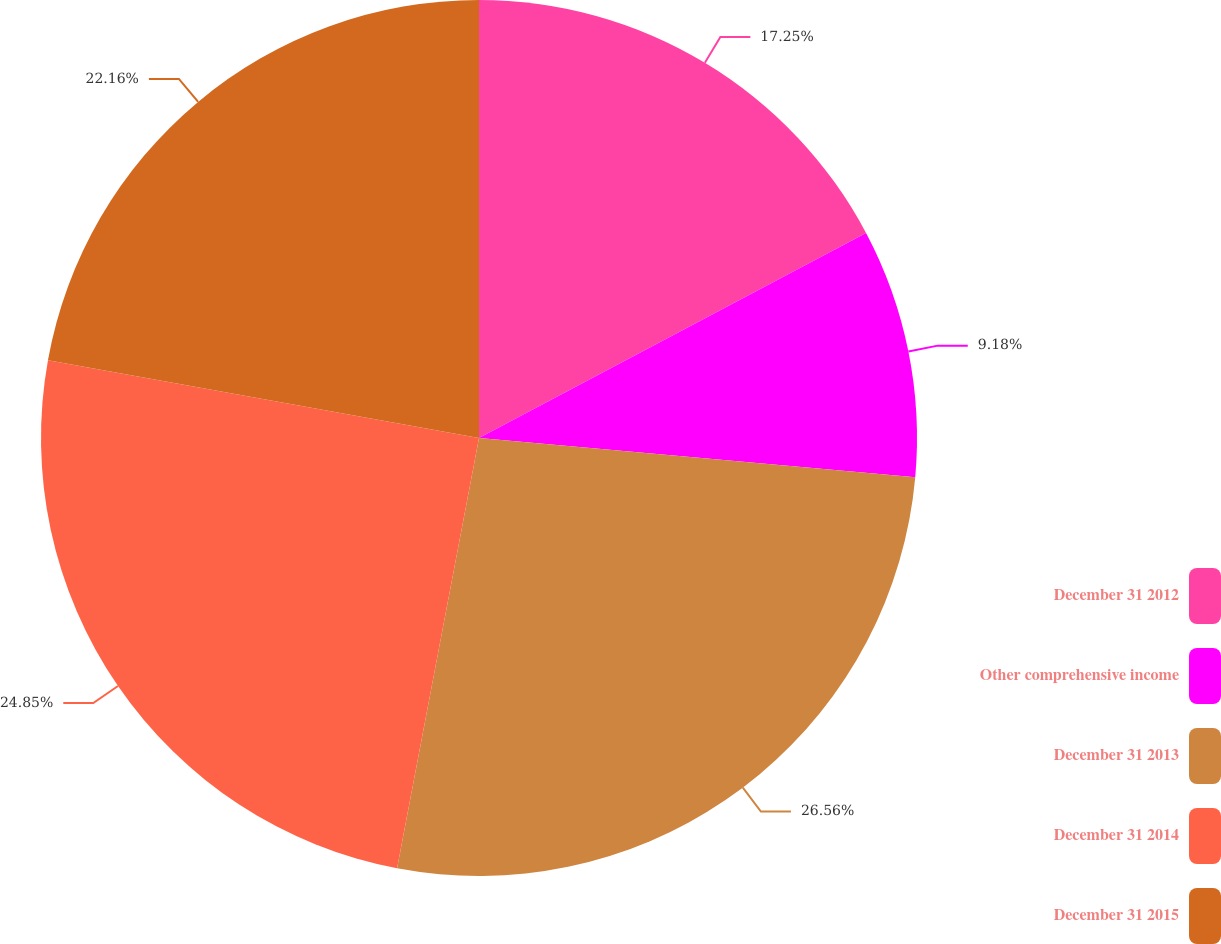<chart> <loc_0><loc_0><loc_500><loc_500><pie_chart><fcel>December 31 2012<fcel>Other comprehensive income<fcel>December 31 2013<fcel>December 31 2014<fcel>December 31 2015<nl><fcel>17.25%<fcel>9.18%<fcel>26.57%<fcel>24.85%<fcel>22.16%<nl></chart> 